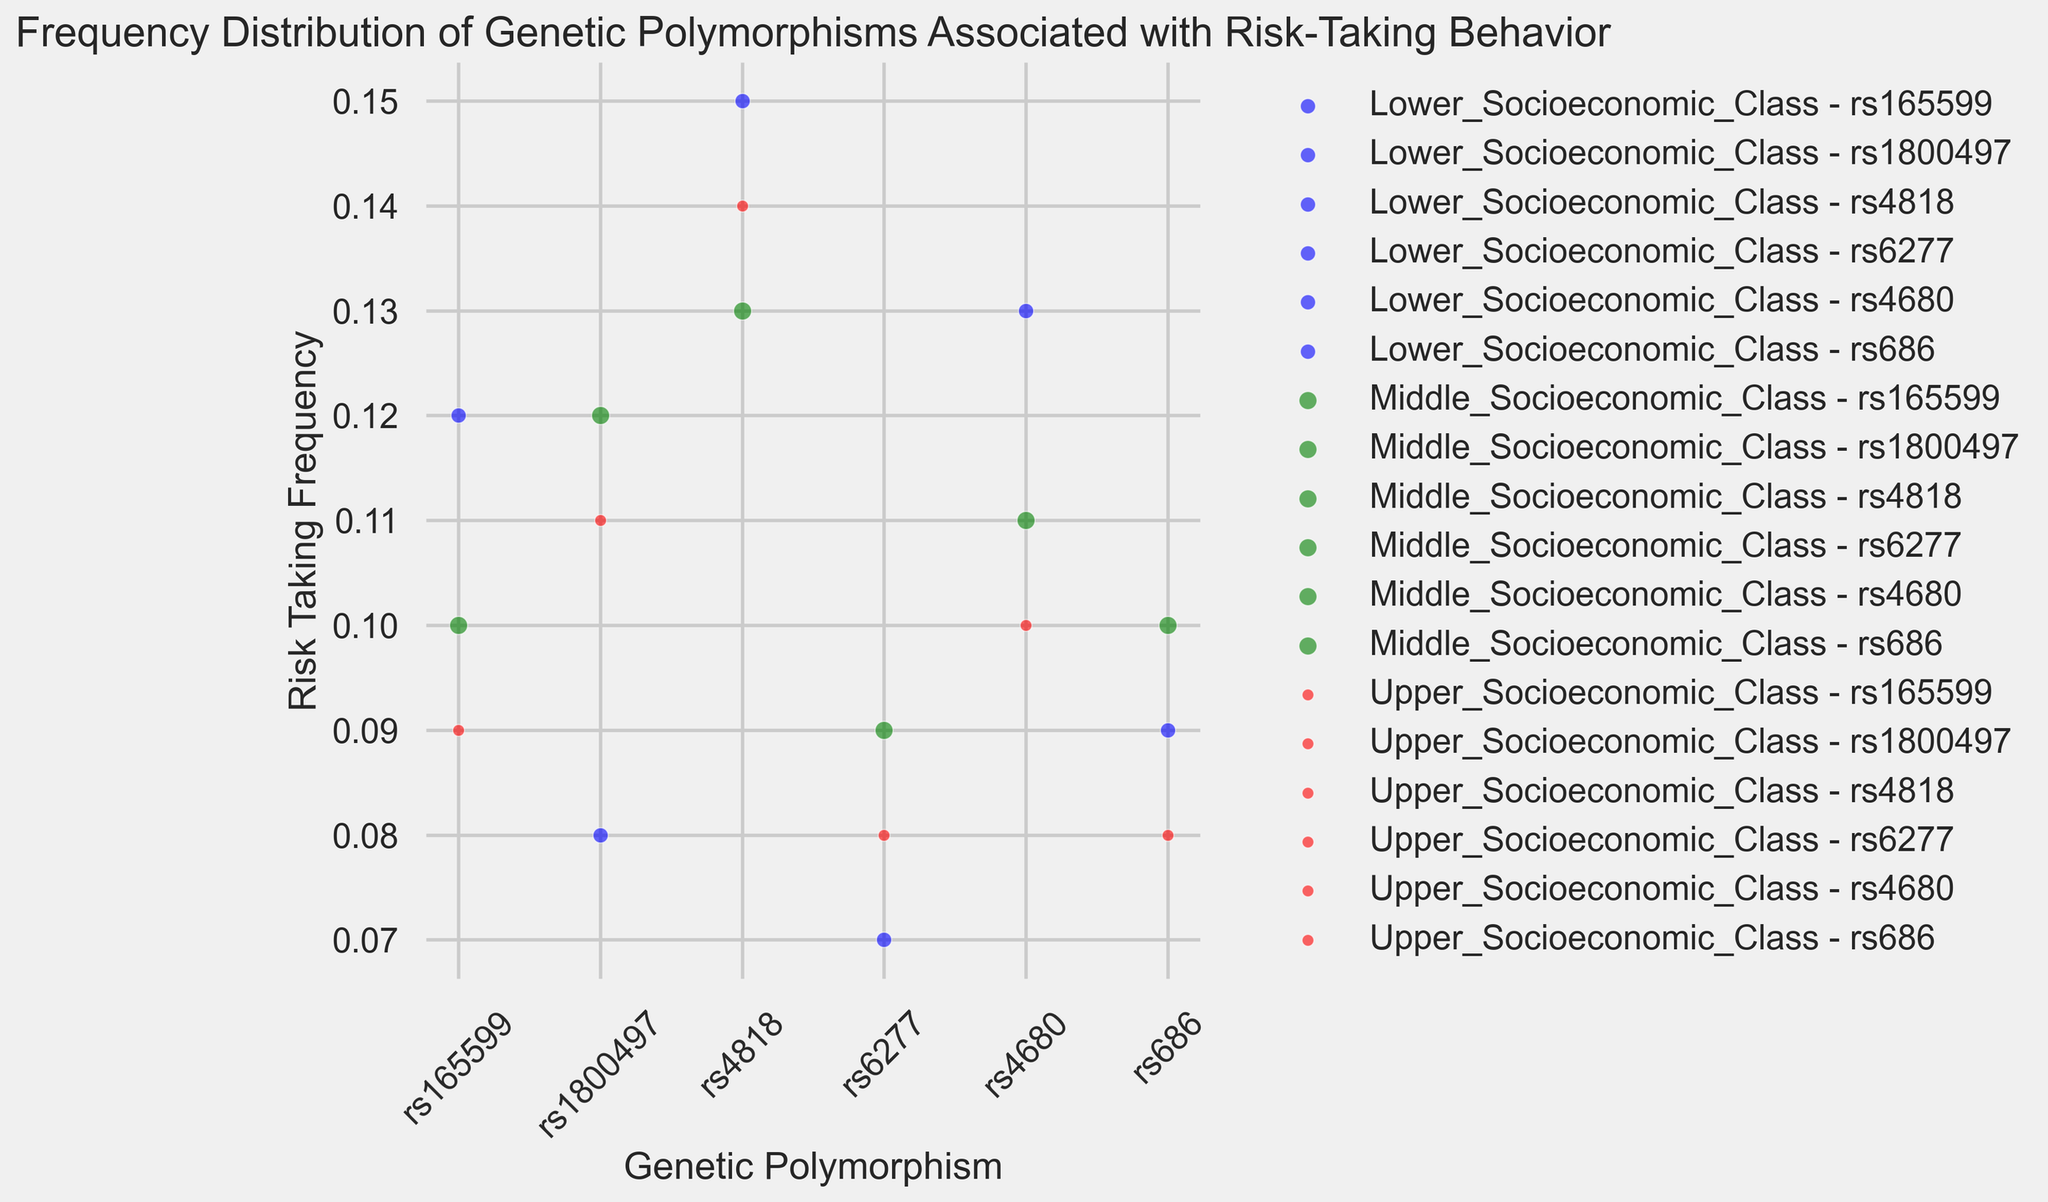What is the risk-taking frequency associated with the rs165599 polymorphism in the Lower, Middle, and Upper Socioeconomic Classes? Check the bubbles corresponding to the rs165599 polymorphism in the Lower (blue), Middle (green), and Upper (red) Socioeconomic Classes and read their risk-taking frequencies on the y-axis.
Answer: Lower: 0.12, Middle: 0.10, Upper: 0.09 Which genetic polymorphism has the highest risk-taking frequency in the Lower Socioeconomic Class? Look at the bubbles colored in blue and locate which one reaches the highest point on the y-axis.
Answer: rs4818 How does the risk-taking frequency of rs4680 compare between the Middle and Upper Socioeconomic Classes? Compare the height of the bubbles (green for Middle, red for Upper) corresponding to the rs4680 polymorphism.
Answer: Higher in Middle Class Which socioeconomic class has the largest bubble for the rs6277 polymorphism, and what does it indicate? Compare the size of the bubbles for the rs6277 polymorphism across all classes (blue for Lower, green for Middle, red for Upper). The largest bubble indicates the class with the highest population size.
Answer: Middle Class; the largest population size What is the average risk-taking frequency for the rs686 polymorphism across all socioeconomic classes? Sum the risk-taking frequencies for rs686 across all classes and divide by the number of classes. (0.09 + 0.10 + 0.08) / 3 = 0.09
Answer: 0.09 Which genetic polymorphism in the Lower Socioeconomic Class has a population size of 5000 and a risk-taking frequency between 0.10 and 0.15? Check the blue bubbles for the Lower Socioeconomic Class and identify the one with a population size of 5000 and y-values between 0.10 and 0.15.
Answer: rs4680 For the rs1800497 polymorphism, which class has the highest risk-taking frequency? Compare the height of the bubbles associated with rs1800497 across all classes (blue, green, red).
Answer: Middle Class What is the difference in risk-taking frequency for the rs4818 polymorphism between the Middle and Lower Socioeconomic Classes? Subtract the risk-taking frequency in the Lower Class from that in the Middle Class. (0.13 - 0.15) = -0.02
Answer: -0.02 How many different genetic polymorphisms are plotted for the Upper Socioeconomic Class? Count the number of distinct bubbles colored in red, based on their genetic polymorphisms.
Answer: 5 